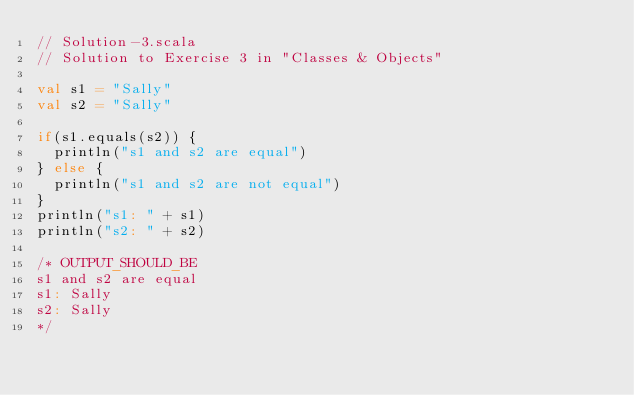Convert code to text. <code><loc_0><loc_0><loc_500><loc_500><_Scala_>// Solution-3.scala
// Solution to Exercise 3 in "Classes & Objects"

val s1 = "Sally"
val s2 = "Sally"

if(s1.equals(s2)) {
  println("s1 and s2 are equal")
} else {
  println("s1 and s2 are not equal")
}
println("s1: " + s1)
println("s2: " + s2)

/* OUTPUT_SHOULD_BE
s1 and s2 are equal
s1: Sally
s2: Sally
*/
</code> 